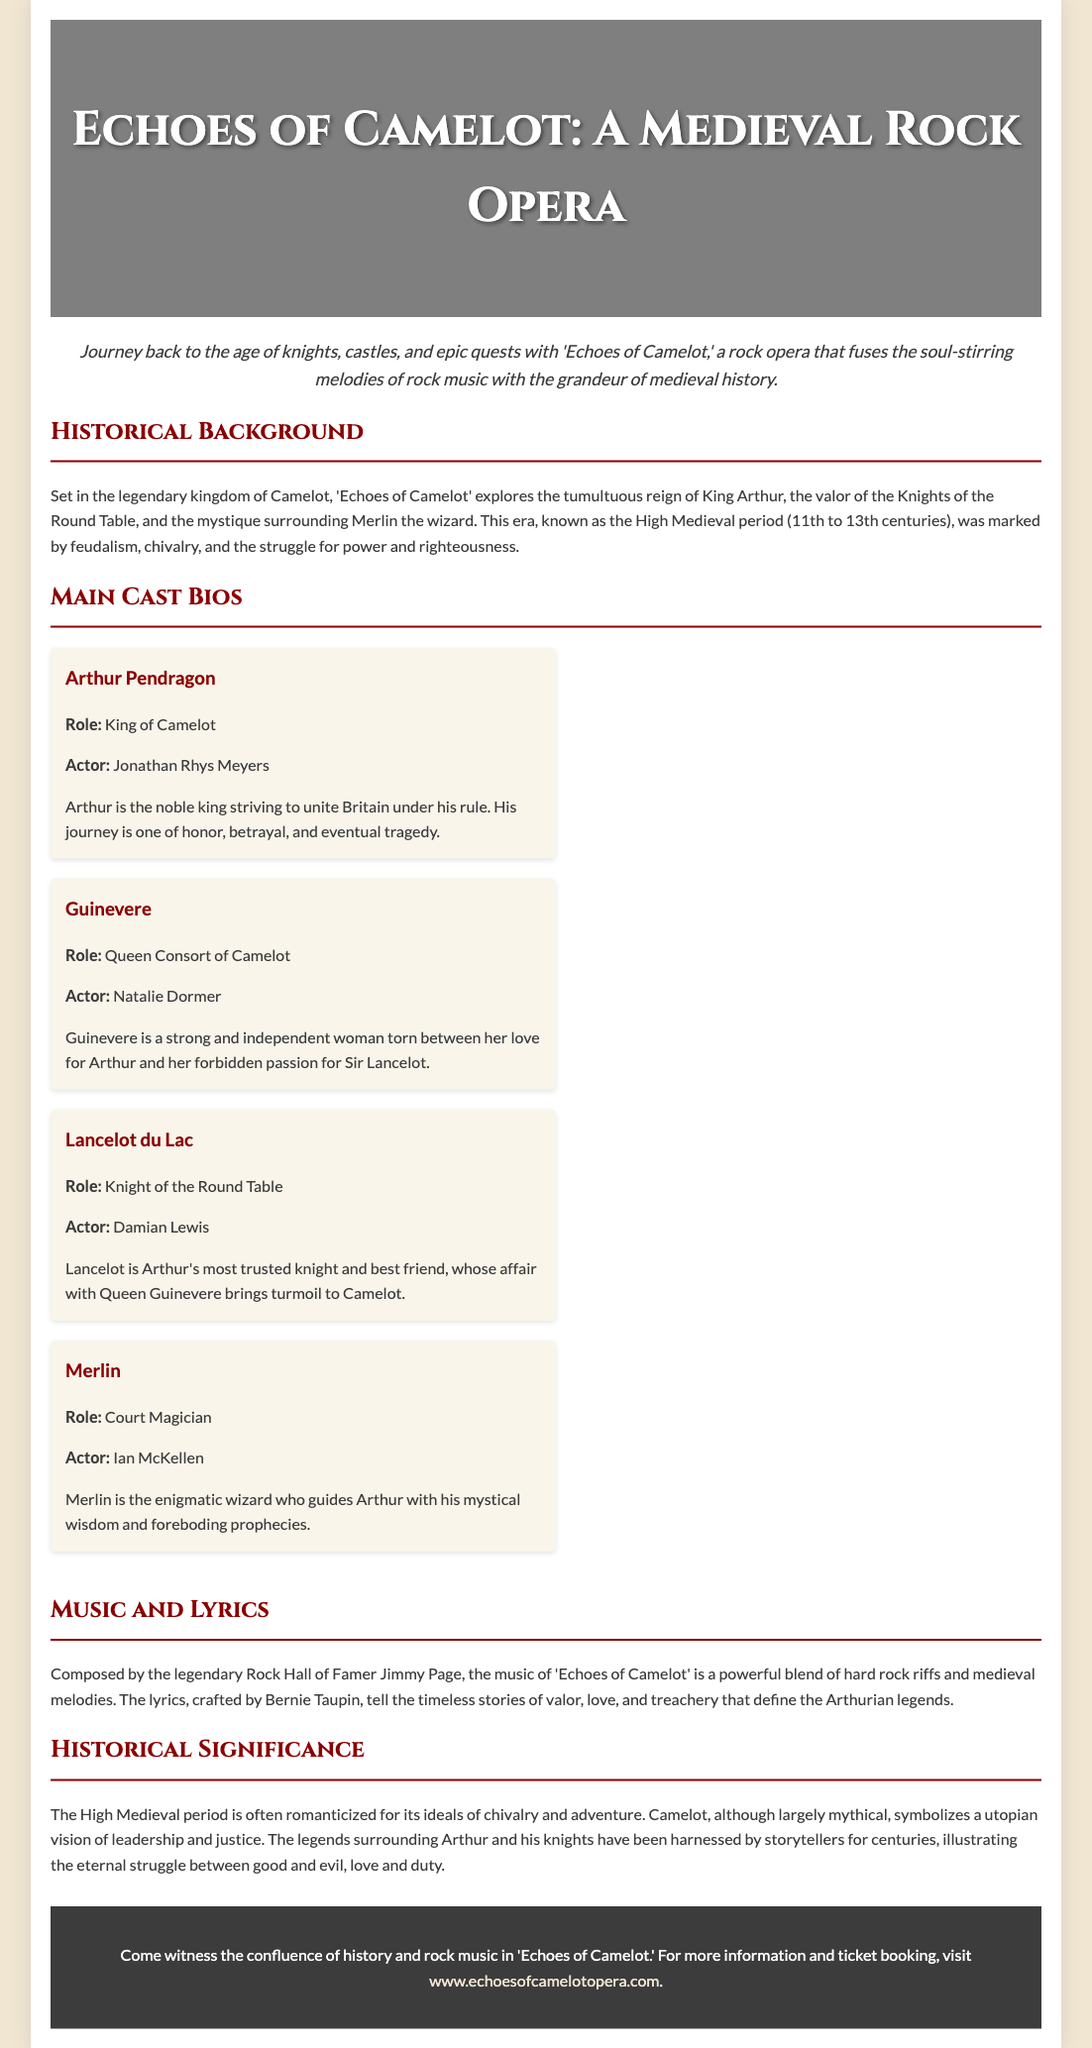What is the title of the rock opera? The title of the rock opera is mentioned prominently in the header of the document.
Answer: Echoes of Camelot Who plays King Arthur? The document provides the cast bios, which include the actor for each role.
Answer: Jonathan Rhys Meyers What historical period is depicted in the rock opera? The historical background section specifies the time period portrayed in the rock opera.
Answer: High Medieval period Which character is described as the Court Magician? The cast bios mention the roles of each character, including Merlin.
Answer: Merlin Who composed the music for the rock opera? The music section credits the composer responsible for the rock opera's score.
Answer: Jimmy Page 